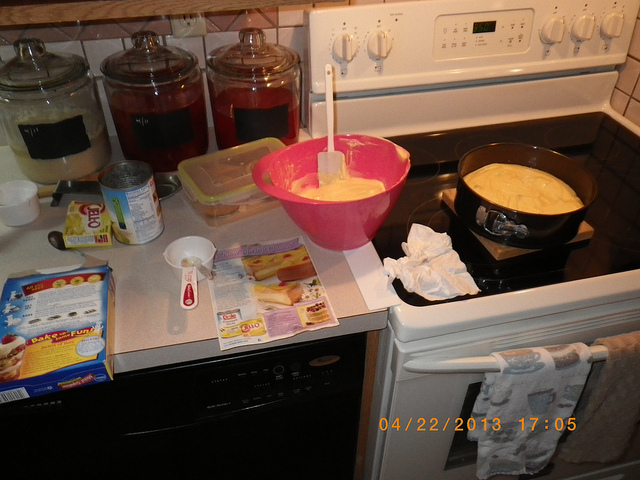Extract all visible text content from this image. 05 17 2013 22 04 